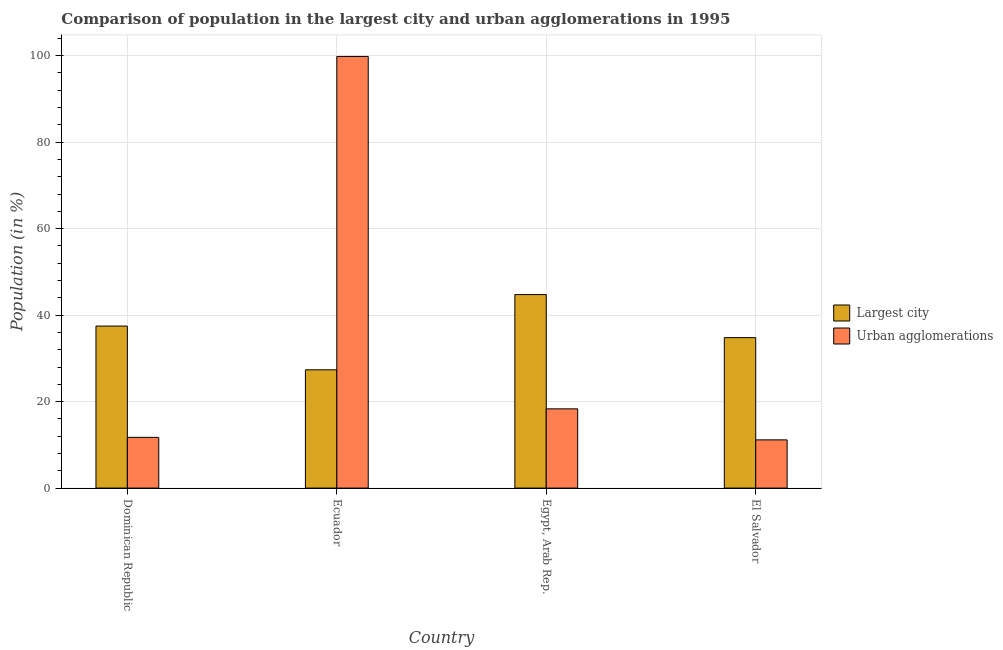Are the number of bars per tick equal to the number of legend labels?
Ensure brevity in your answer.  Yes. What is the label of the 3rd group of bars from the left?
Offer a terse response. Egypt, Arab Rep. In how many cases, is the number of bars for a given country not equal to the number of legend labels?
Provide a succinct answer. 0. What is the population in urban agglomerations in Egypt, Arab Rep.?
Your answer should be very brief. 18.33. Across all countries, what is the maximum population in the largest city?
Offer a terse response. 44.75. Across all countries, what is the minimum population in urban agglomerations?
Give a very brief answer. 11.15. In which country was the population in urban agglomerations maximum?
Give a very brief answer. Ecuador. In which country was the population in the largest city minimum?
Ensure brevity in your answer.  Ecuador. What is the total population in urban agglomerations in the graph?
Your response must be concise. 141.02. What is the difference between the population in urban agglomerations in Ecuador and that in Egypt, Arab Rep.?
Your response must be concise. 81.48. What is the difference between the population in the largest city in Ecuador and the population in urban agglomerations in Egypt, Arab Rep.?
Provide a succinct answer. 9.02. What is the average population in urban agglomerations per country?
Your answer should be very brief. 35.26. What is the difference between the population in urban agglomerations and population in the largest city in Dominican Republic?
Your response must be concise. -25.73. In how many countries, is the population in urban agglomerations greater than 72 %?
Your response must be concise. 1. What is the ratio of the population in the largest city in Egypt, Arab Rep. to that in El Salvador?
Provide a succinct answer. 1.29. What is the difference between the highest and the second highest population in urban agglomerations?
Ensure brevity in your answer.  81.48. What is the difference between the highest and the lowest population in urban agglomerations?
Provide a short and direct response. 88.66. In how many countries, is the population in urban agglomerations greater than the average population in urban agglomerations taken over all countries?
Offer a terse response. 1. What does the 1st bar from the left in El Salvador represents?
Your answer should be compact. Largest city. What does the 2nd bar from the right in El Salvador represents?
Ensure brevity in your answer.  Largest city. How many bars are there?
Provide a succinct answer. 8. Are all the bars in the graph horizontal?
Your answer should be compact. No. How many countries are there in the graph?
Your answer should be compact. 4. What is the difference between two consecutive major ticks on the Y-axis?
Provide a short and direct response. 20. Are the values on the major ticks of Y-axis written in scientific E-notation?
Provide a succinct answer. No. Does the graph contain grids?
Your answer should be very brief. Yes. How are the legend labels stacked?
Offer a terse response. Vertical. What is the title of the graph?
Provide a short and direct response. Comparison of population in the largest city and urban agglomerations in 1995. Does "Merchandise imports" appear as one of the legend labels in the graph?
Offer a terse response. No. What is the label or title of the X-axis?
Give a very brief answer. Country. What is the label or title of the Y-axis?
Give a very brief answer. Population (in %). What is the Population (in %) of Largest city in Dominican Republic?
Offer a terse response. 37.47. What is the Population (in %) of Urban agglomerations in Dominican Republic?
Offer a terse response. 11.73. What is the Population (in %) of Largest city in Ecuador?
Offer a terse response. 27.35. What is the Population (in %) of Urban agglomerations in Ecuador?
Offer a very short reply. 99.81. What is the Population (in %) in Largest city in Egypt, Arab Rep.?
Ensure brevity in your answer.  44.75. What is the Population (in %) of Urban agglomerations in Egypt, Arab Rep.?
Your answer should be compact. 18.33. What is the Population (in %) in Largest city in El Salvador?
Offer a terse response. 34.79. What is the Population (in %) in Urban agglomerations in El Salvador?
Ensure brevity in your answer.  11.15. Across all countries, what is the maximum Population (in %) of Largest city?
Ensure brevity in your answer.  44.75. Across all countries, what is the maximum Population (in %) in Urban agglomerations?
Make the answer very short. 99.81. Across all countries, what is the minimum Population (in %) of Largest city?
Provide a short and direct response. 27.35. Across all countries, what is the minimum Population (in %) in Urban agglomerations?
Provide a short and direct response. 11.15. What is the total Population (in %) of Largest city in the graph?
Your answer should be compact. 144.36. What is the total Population (in %) of Urban agglomerations in the graph?
Offer a terse response. 141.02. What is the difference between the Population (in %) of Largest city in Dominican Republic and that in Ecuador?
Your answer should be compact. 10.11. What is the difference between the Population (in %) of Urban agglomerations in Dominican Republic and that in Ecuador?
Give a very brief answer. -88.08. What is the difference between the Population (in %) of Largest city in Dominican Republic and that in Egypt, Arab Rep.?
Give a very brief answer. -7.28. What is the difference between the Population (in %) in Urban agglomerations in Dominican Republic and that in Egypt, Arab Rep.?
Offer a terse response. -6.6. What is the difference between the Population (in %) in Largest city in Dominican Republic and that in El Salvador?
Provide a short and direct response. 2.67. What is the difference between the Population (in %) of Urban agglomerations in Dominican Republic and that in El Salvador?
Your answer should be compact. 0.58. What is the difference between the Population (in %) of Largest city in Ecuador and that in Egypt, Arab Rep.?
Provide a short and direct response. -17.4. What is the difference between the Population (in %) in Urban agglomerations in Ecuador and that in Egypt, Arab Rep.?
Offer a very short reply. 81.48. What is the difference between the Population (in %) of Largest city in Ecuador and that in El Salvador?
Your answer should be very brief. -7.44. What is the difference between the Population (in %) of Urban agglomerations in Ecuador and that in El Salvador?
Ensure brevity in your answer.  88.66. What is the difference between the Population (in %) of Largest city in Egypt, Arab Rep. and that in El Salvador?
Your response must be concise. 9.96. What is the difference between the Population (in %) of Urban agglomerations in Egypt, Arab Rep. and that in El Salvador?
Your answer should be compact. 7.18. What is the difference between the Population (in %) in Largest city in Dominican Republic and the Population (in %) in Urban agglomerations in Ecuador?
Give a very brief answer. -62.35. What is the difference between the Population (in %) of Largest city in Dominican Republic and the Population (in %) of Urban agglomerations in Egypt, Arab Rep.?
Offer a very short reply. 19.14. What is the difference between the Population (in %) in Largest city in Dominican Republic and the Population (in %) in Urban agglomerations in El Salvador?
Offer a terse response. 26.31. What is the difference between the Population (in %) in Largest city in Ecuador and the Population (in %) in Urban agglomerations in Egypt, Arab Rep.?
Provide a short and direct response. 9.02. What is the difference between the Population (in %) in Largest city in Ecuador and the Population (in %) in Urban agglomerations in El Salvador?
Give a very brief answer. 16.2. What is the difference between the Population (in %) of Largest city in Egypt, Arab Rep. and the Population (in %) of Urban agglomerations in El Salvador?
Offer a terse response. 33.6. What is the average Population (in %) of Largest city per country?
Make the answer very short. 36.09. What is the average Population (in %) of Urban agglomerations per country?
Offer a terse response. 35.26. What is the difference between the Population (in %) in Largest city and Population (in %) in Urban agglomerations in Dominican Republic?
Provide a succinct answer. 25.73. What is the difference between the Population (in %) in Largest city and Population (in %) in Urban agglomerations in Ecuador?
Offer a very short reply. -72.46. What is the difference between the Population (in %) of Largest city and Population (in %) of Urban agglomerations in Egypt, Arab Rep.?
Ensure brevity in your answer.  26.42. What is the difference between the Population (in %) of Largest city and Population (in %) of Urban agglomerations in El Salvador?
Keep it short and to the point. 23.64. What is the ratio of the Population (in %) in Largest city in Dominican Republic to that in Ecuador?
Make the answer very short. 1.37. What is the ratio of the Population (in %) in Urban agglomerations in Dominican Republic to that in Ecuador?
Your response must be concise. 0.12. What is the ratio of the Population (in %) of Largest city in Dominican Republic to that in Egypt, Arab Rep.?
Provide a short and direct response. 0.84. What is the ratio of the Population (in %) of Urban agglomerations in Dominican Republic to that in Egypt, Arab Rep.?
Your answer should be very brief. 0.64. What is the ratio of the Population (in %) of Largest city in Dominican Republic to that in El Salvador?
Provide a short and direct response. 1.08. What is the ratio of the Population (in %) in Urban agglomerations in Dominican Republic to that in El Salvador?
Offer a terse response. 1.05. What is the ratio of the Population (in %) of Largest city in Ecuador to that in Egypt, Arab Rep.?
Provide a succinct answer. 0.61. What is the ratio of the Population (in %) of Urban agglomerations in Ecuador to that in Egypt, Arab Rep.?
Your response must be concise. 5.45. What is the ratio of the Population (in %) in Largest city in Ecuador to that in El Salvador?
Give a very brief answer. 0.79. What is the ratio of the Population (in %) of Urban agglomerations in Ecuador to that in El Salvador?
Offer a terse response. 8.95. What is the ratio of the Population (in %) of Largest city in Egypt, Arab Rep. to that in El Salvador?
Make the answer very short. 1.29. What is the ratio of the Population (in %) in Urban agglomerations in Egypt, Arab Rep. to that in El Salvador?
Offer a very short reply. 1.64. What is the difference between the highest and the second highest Population (in %) of Largest city?
Your answer should be compact. 7.28. What is the difference between the highest and the second highest Population (in %) of Urban agglomerations?
Offer a very short reply. 81.48. What is the difference between the highest and the lowest Population (in %) of Largest city?
Give a very brief answer. 17.4. What is the difference between the highest and the lowest Population (in %) in Urban agglomerations?
Your response must be concise. 88.66. 